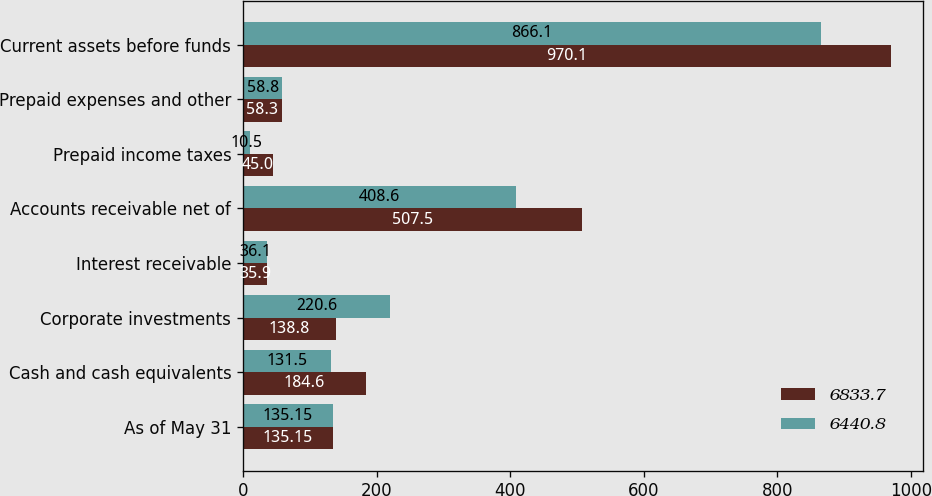Convert chart to OTSL. <chart><loc_0><loc_0><loc_500><loc_500><stacked_bar_chart><ecel><fcel>As of May 31<fcel>Cash and cash equivalents<fcel>Corporate investments<fcel>Interest receivable<fcel>Accounts receivable net of<fcel>Prepaid income taxes<fcel>Prepaid expenses and other<fcel>Current assets before funds<nl><fcel>6833.7<fcel>135.15<fcel>184.6<fcel>138.8<fcel>35.9<fcel>507.5<fcel>45<fcel>58.3<fcel>970.1<nl><fcel>6440.8<fcel>135.15<fcel>131.5<fcel>220.6<fcel>36.1<fcel>408.6<fcel>10.5<fcel>58.8<fcel>866.1<nl></chart> 